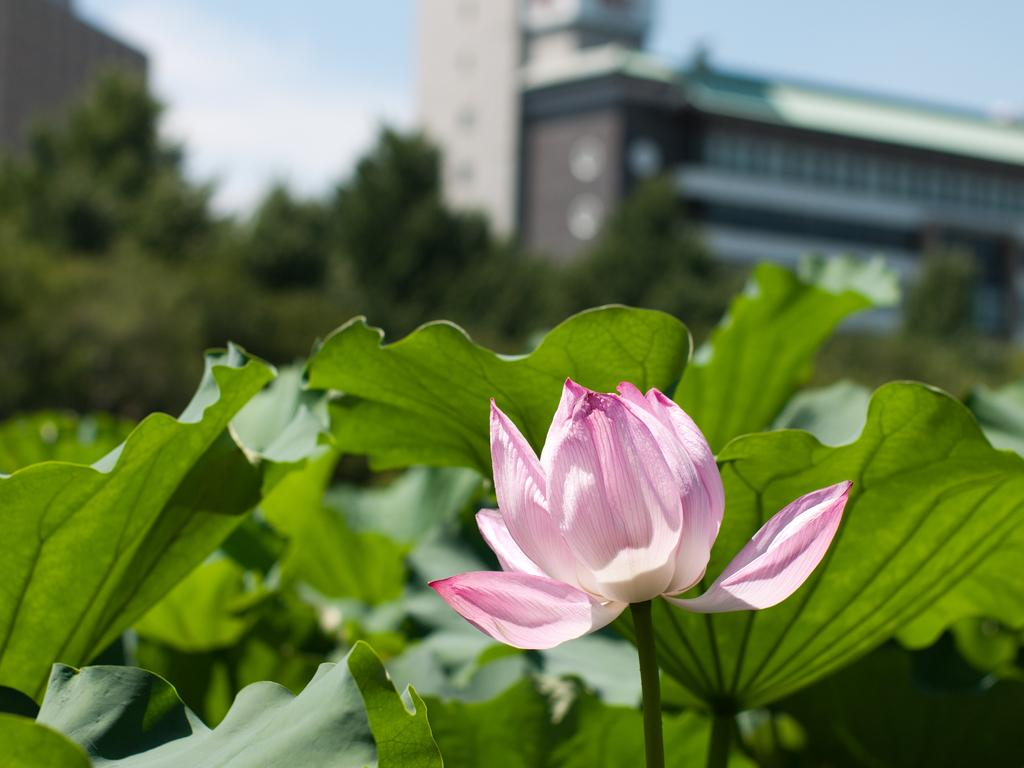What type of plant can be seen in the image? There is a flower with a stem in the image. What other parts of the plant are visible? Leaves are visible in the image. What can be seen in the background of the image? There are trees and buildings in the background of the image. What is visible in the sky in the image? The sky is visible in the background of the image. What type of ship can be seen sailing in the image? There is no ship present in the image; it features a flower with a stem, leaves, and a background with trees, buildings, and the sky. 